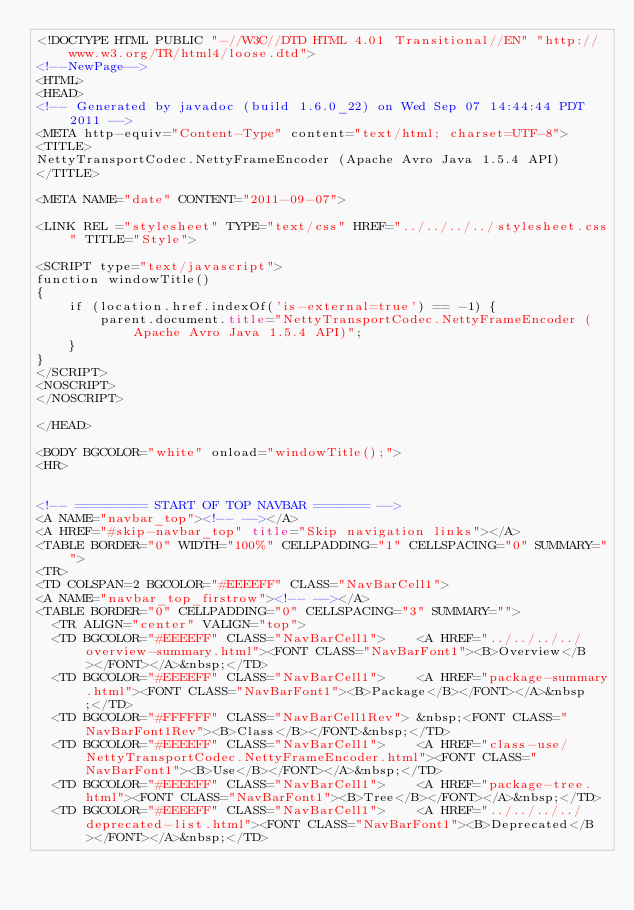<code> <loc_0><loc_0><loc_500><loc_500><_HTML_><!DOCTYPE HTML PUBLIC "-//W3C//DTD HTML 4.01 Transitional//EN" "http://www.w3.org/TR/html4/loose.dtd">
<!--NewPage-->
<HTML>
<HEAD>
<!-- Generated by javadoc (build 1.6.0_22) on Wed Sep 07 14:44:44 PDT 2011 -->
<META http-equiv="Content-Type" content="text/html; charset=UTF-8">
<TITLE>
NettyTransportCodec.NettyFrameEncoder (Apache Avro Java 1.5.4 API)
</TITLE>

<META NAME="date" CONTENT="2011-09-07">

<LINK REL ="stylesheet" TYPE="text/css" HREF="../../../../stylesheet.css" TITLE="Style">

<SCRIPT type="text/javascript">
function windowTitle()
{
    if (location.href.indexOf('is-external=true') == -1) {
        parent.document.title="NettyTransportCodec.NettyFrameEncoder (Apache Avro Java 1.5.4 API)";
    }
}
</SCRIPT>
<NOSCRIPT>
</NOSCRIPT>

</HEAD>

<BODY BGCOLOR="white" onload="windowTitle();">
<HR>


<!-- ========= START OF TOP NAVBAR ======= -->
<A NAME="navbar_top"><!-- --></A>
<A HREF="#skip-navbar_top" title="Skip navigation links"></A>
<TABLE BORDER="0" WIDTH="100%" CELLPADDING="1" CELLSPACING="0" SUMMARY="">
<TR>
<TD COLSPAN=2 BGCOLOR="#EEEEFF" CLASS="NavBarCell1">
<A NAME="navbar_top_firstrow"><!-- --></A>
<TABLE BORDER="0" CELLPADDING="0" CELLSPACING="3" SUMMARY="">
  <TR ALIGN="center" VALIGN="top">
  <TD BGCOLOR="#EEEEFF" CLASS="NavBarCell1">    <A HREF="../../../../overview-summary.html"><FONT CLASS="NavBarFont1"><B>Overview</B></FONT></A>&nbsp;</TD>
  <TD BGCOLOR="#EEEEFF" CLASS="NavBarCell1">    <A HREF="package-summary.html"><FONT CLASS="NavBarFont1"><B>Package</B></FONT></A>&nbsp;</TD>
  <TD BGCOLOR="#FFFFFF" CLASS="NavBarCell1Rev"> &nbsp;<FONT CLASS="NavBarFont1Rev"><B>Class</B></FONT>&nbsp;</TD>
  <TD BGCOLOR="#EEEEFF" CLASS="NavBarCell1">    <A HREF="class-use/NettyTransportCodec.NettyFrameEncoder.html"><FONT CLASS="NavBarFont1"><B>Use</B></FONT></A>&nbsp;</TD>
  <TD BGCOLOR="#EEEEFF" CLASS="NavBarCell1">    <A HREF="package-tree.html"><FONT CLASS="NavBarFont1"><B>Tree</B></FONT></A>&nbsp;</TD>
  <TD BGCOLOR="#EEEEFF" CLASS="NavBarCell1">    <A HREF="../../../../deprecated-list.html"><FONT CLASS="NavBarFont1"><B>Deprecated</B></FONT></A>&nbsp;</TD></code> 